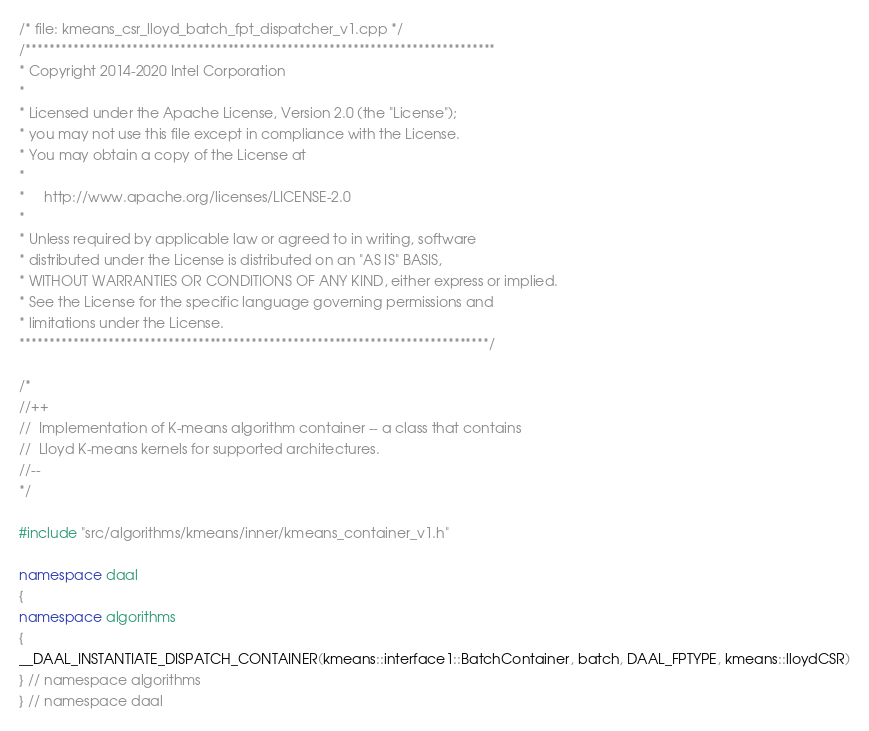<code> <loc_0><loc_0><loc_500><loc_500><_C++_>/* file: kmeans_csr_lloyd_batch_fpt_dispatcher_v1.cpp */
/*******************************************************************************
* Copyright 2014-2020 Intel Corporation
*
* Licensed under the Apache License, Version 2.0 (the "License");
* you may not use this file except in compliance with the License.
* You may obtain a copy of the License at
*
*     http://www.apache.org/licenses/LICENSE-2.0
*
* Unless required by applicable law or agreed to in writing, software
* distributed under the License is distributed on an "AS IS" BASIS,
* WITHOUT WARRANTIES OR CONDITIONS OF ANY KIND, either express or implied.
* See the License for the specific language governing permissions and
* limitations under the License.
*******************************************************************************/

/*
//++
//  Implementation of K-means algorithm container -- a class that contains
//  Lloyd K-means kernels for supported architectures.
//--
*/

#include "src/algorithms/kmeans/inner/kmeans_container_v1.h"

namespace daal
{
namespace algorithms
{
__DAAL_INSTANTIATE_DISPATCH_CONTAINER(kmeans::interface1::BatchContainer, batch, DAAL_FPTYPE, kmeans::lloydCSR)
} // namespace algorithms
} // namespace daal
</code> 